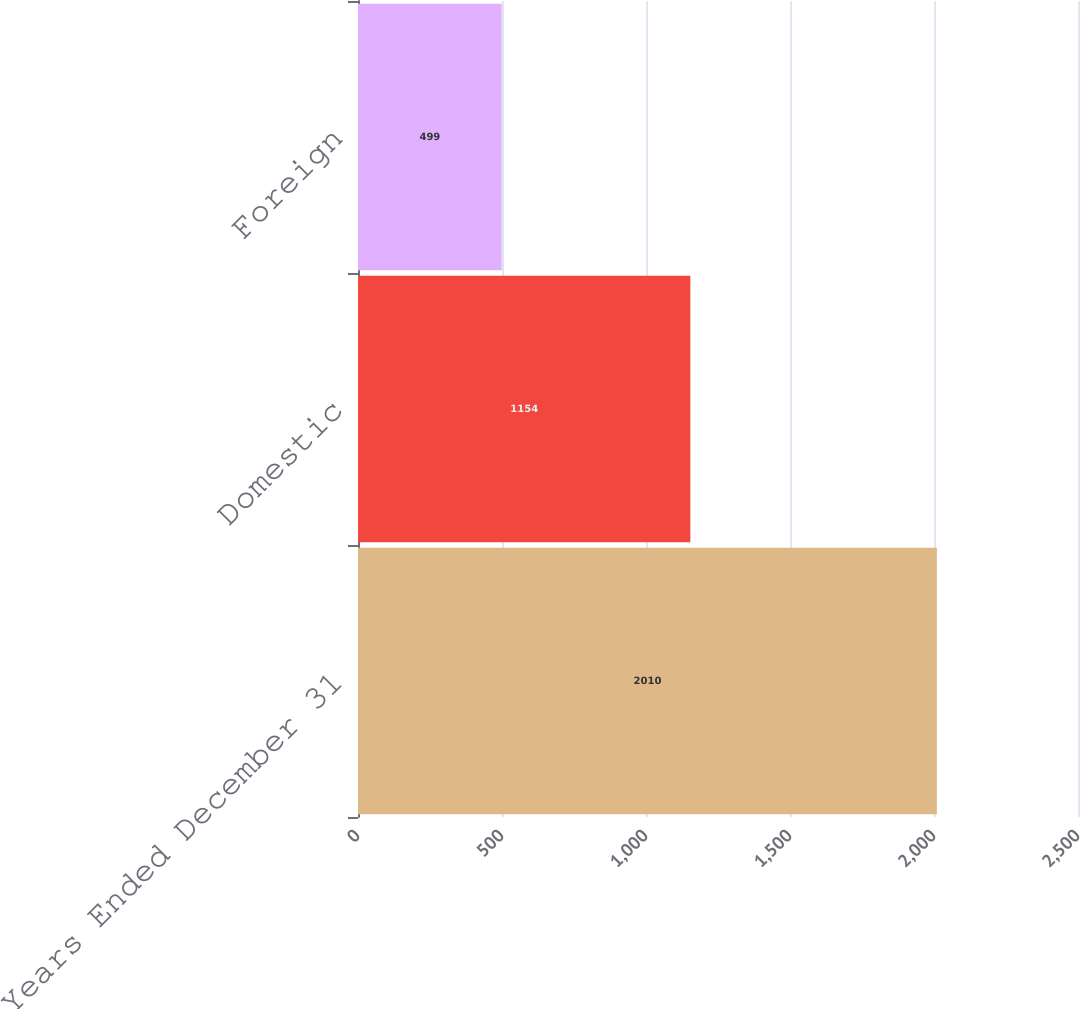Convert chart to OTSL. <chart><loc_0><loc_0><loc_500><loc_500><bar_chart><fcel>Years Ended December 31<fcel>Domestic<fcel>Foreign<nl><fcel>2010<fcel>1154<fcel>499<nl></chart> 